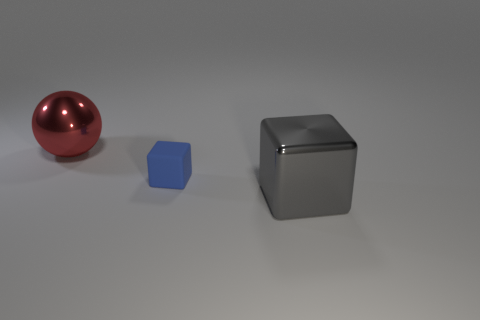What number of large gray cubes are the same material as the large sphere?
Your response must be concise. 1. Are there more shiny things that are behind the small blue thing than brown metal things?
Your response must be concise. Yes. Are there any tiny blue matte things of the same shape as the big gray metal thing?
Provide a succinct answer. Yes. What number of objects are big red spheres or shiny objects?
Give a very brief answer. 2. There is a cube that is on the left side of the large shiny object that is on the right side of the big red ball; what number of cubes are to the right of it?
Your answer should be very brief. 1. What is the material of the big object that is the same shape as the small rubber object?
Make the answer very short. Metal. Is the number of large spheres left of the red object less than the number of cubes in front of the tiny blue rubber block?
Offer a very short reply. Yes. What number of other objects are the same size as the ball?
Provide a succinct answer. 1. What shape is the large metal object on the left side of the large shiny thing in front of the big object to the left of the big gray metal cube?
Your response must be concise. Sphere. How many yellow things are either large cubes or matte cylinders?
Your response must be concise. 0. 